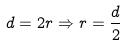<formula> <loc_0><loc_0><loc_500><loc_500>d = 2 r \Rightarrow r = \frac { d } { 2 }</formula> 